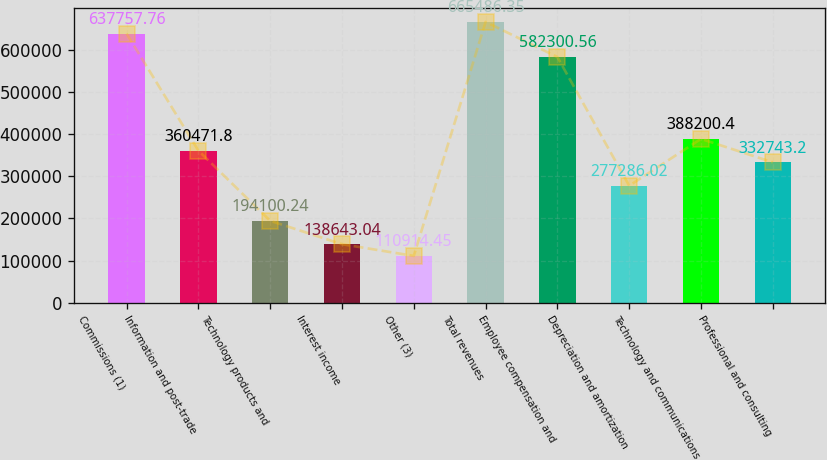Convert chart. <chart><loc_0><loc_0><loc_500><loc_500><bar_chart><fcel>Commissions (1)<fcel>Information and post-trade<fcel>Technology products and<fcel>Interest income<fcel>Other (3)<fcel>Total revenues<fcel>Employee compensation and<fcel>Depreciation and amortization<fcel>Technology and communications<fcel>Professional and consulting<nl><fcel>637758<fcel>360472<fcel>194100<fcel>138643<fcel>110914<fcel>665486<fcel>582301<fcel>277286<fcel>388200<fcel>332743<nl></chart> 